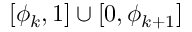Convert formula to latex. <formula><loc_0><loc_0><loc_500><loc_500>[ \phi _ { k } , 1 ] \cup [ 0 , \phi _ { k + 1 } ]</formula> 